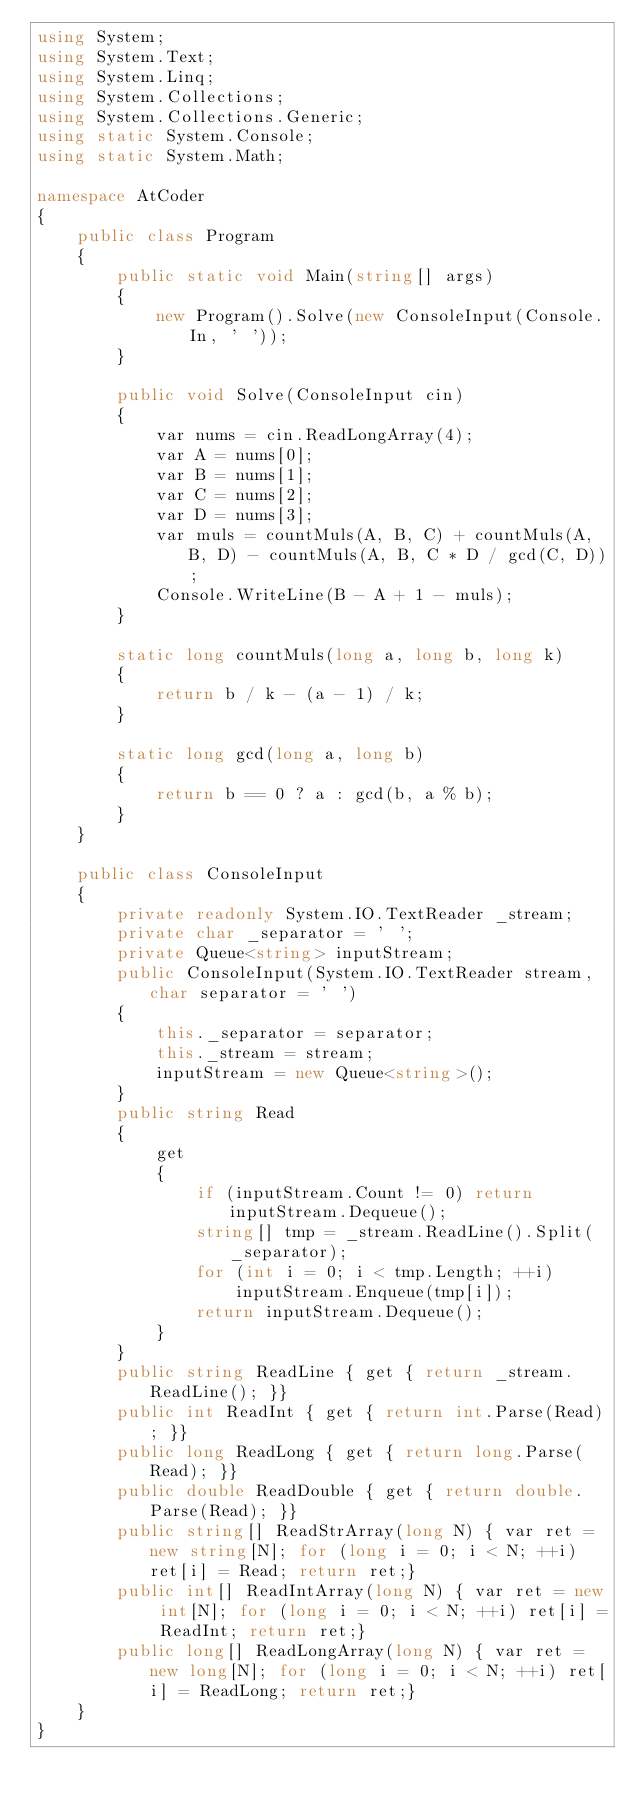Convert code to text. <code><loc_0><loc_0><loc_500><loc_500><_C#_>using System;
using System.Text;
using System.Linq;
using System.Collections;
using System.Collections.Generic;
using static System.Console;
using static System.Math;

namespace AtCoder
{
    public class Program
    {
        public static void Main(string[] args)
        {
            new Program().Solve(new ConsoleInput(Console.In, ' '));
        }

        public void Solve(ConsoleInput cin)
        {
            var nums = cin.ReadLongArray(4);
            var A = nums[0];
            var B = nums[1];
            var C = nums[2];
            var D = nums[3];
            var muls = countMuls(A, B, C) + countMuls(A, B, D) - countMuls(A, B, C * D / gcd(C, D));
            Console.WriteLine(B - A + 1 - muls);
        }

        static long countMuls(long a, long b, long k)
        {
            return b / k - (a - 1) / k;
        }

        static long gcd(long a, long b)
        {
            return b == 0 ? a : gcd(b, a % b);
        }
    }

    public class ConsoleInput
    {
        private readonly System.IO.TextReader _stream;
        private char _separator = ' ';
        private Queue<string> inputStream;
        public ConsoleInput(System.IO.TextReader stream, char separator = ' ')
        {
            this._separator = separator;
            this._stream = stream;
            inputStream = new Queue<string>();
        }
        public string Read
        {
            get
            {
                if (inputStream.Count != 0) return inputStream.Dequeue();
                string[] tmp = _stream.ReadLine().Split(_separator);
                for (int i = 0; i < tmp.Length; ++i)
                    inputStream.Enqueue(tmp[i]);
                return inputStream.Dequeue();
            }
        }
        public string ReadLine { get { return _stream.ReadLine(); }}
        public int ReadInt { get { return int.Parse(Read); }}
        public long ReadLong { get { return long.Parse(Read); }}
        public double ReadDouble { get { return double.Parse(Read); }}
        public string[] ReadStrArray(long N) { var ret = new string[N]; for (long i = 0; i < N; ++i) ret[i] = Read; return ret;}
        public int[] ReadIntArray(long N) { var ret = new int[N]; for (long i = 0; i < N; ++i) ret[i] = ReadInt; return ret;}
        public long[] ReadLongArray(long N) { var ret = new long[N]; for (long i = 0; i < N; ++i) ret[i] = ReadLong; return ret;}
    }
}
</code> 